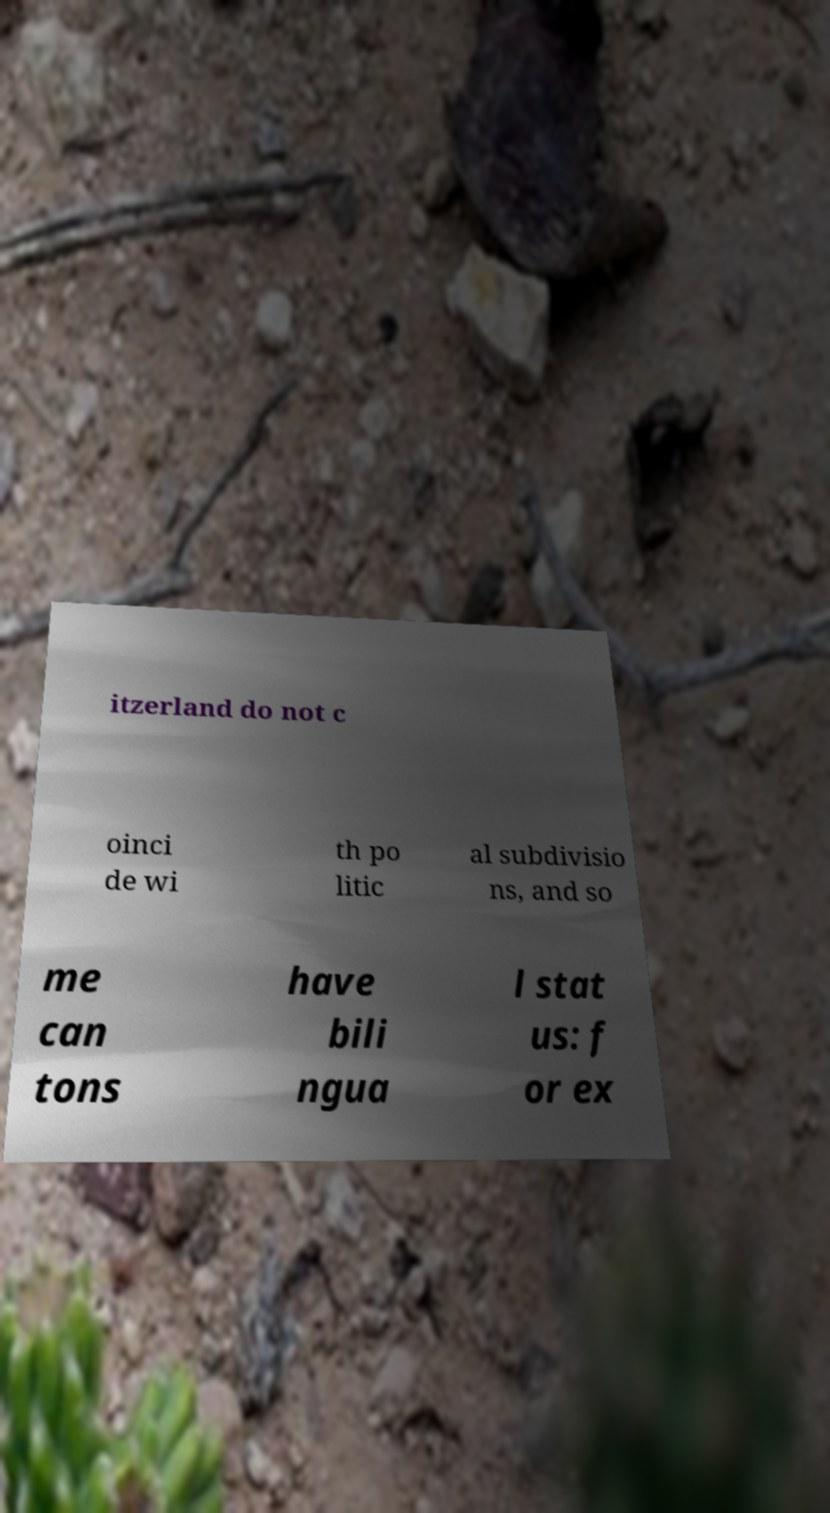Please identify and transcribe the text found in this image. itzerland do not c oinci de wi th po litic al subdivisio ns, and so me can tons have bili ngua l stat us: f or ex 